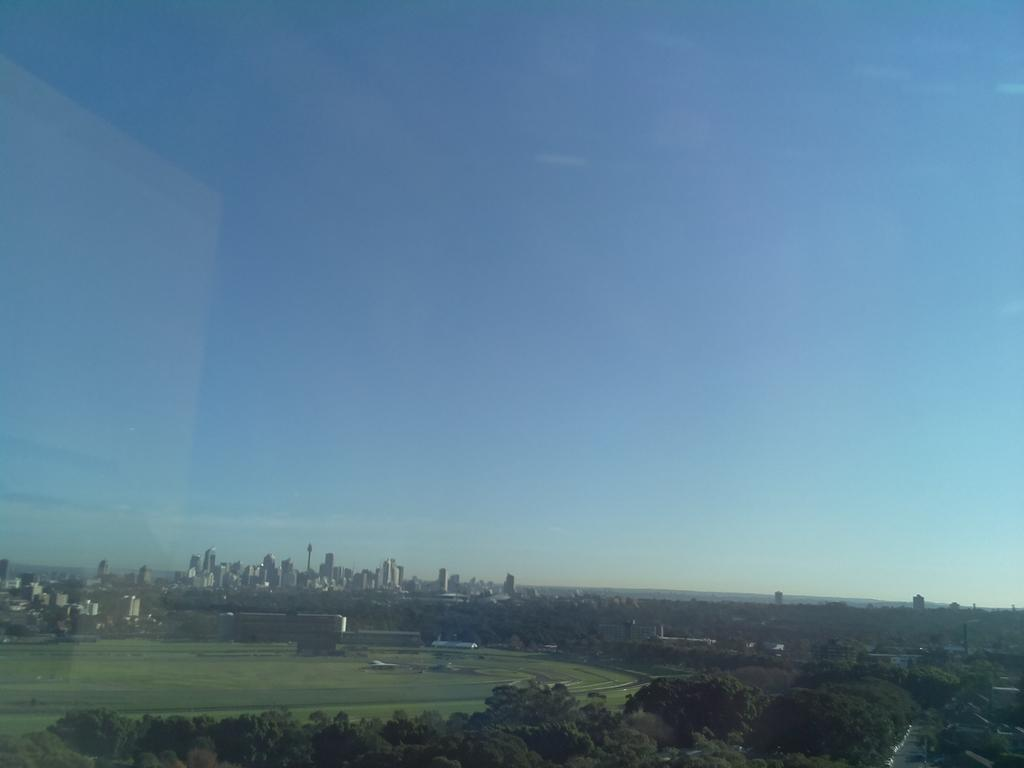What type of structures can be seen in the image? There are buildings in the image. What type of vegetation is present in the image? There are trees in the image. What can be seen on the ground in the image? The ground is visible in the image, and there is grass on it. Are there any objects on the ground in the image? Yes, there are a few objects on the ground. What is visible in the sky in the image? The sky is visible in the image. Can you see any lace in the image? There is no lace present in the image. Are there any animals from a zoo in the image? There is no reference to a zoo or any animals in the image. 